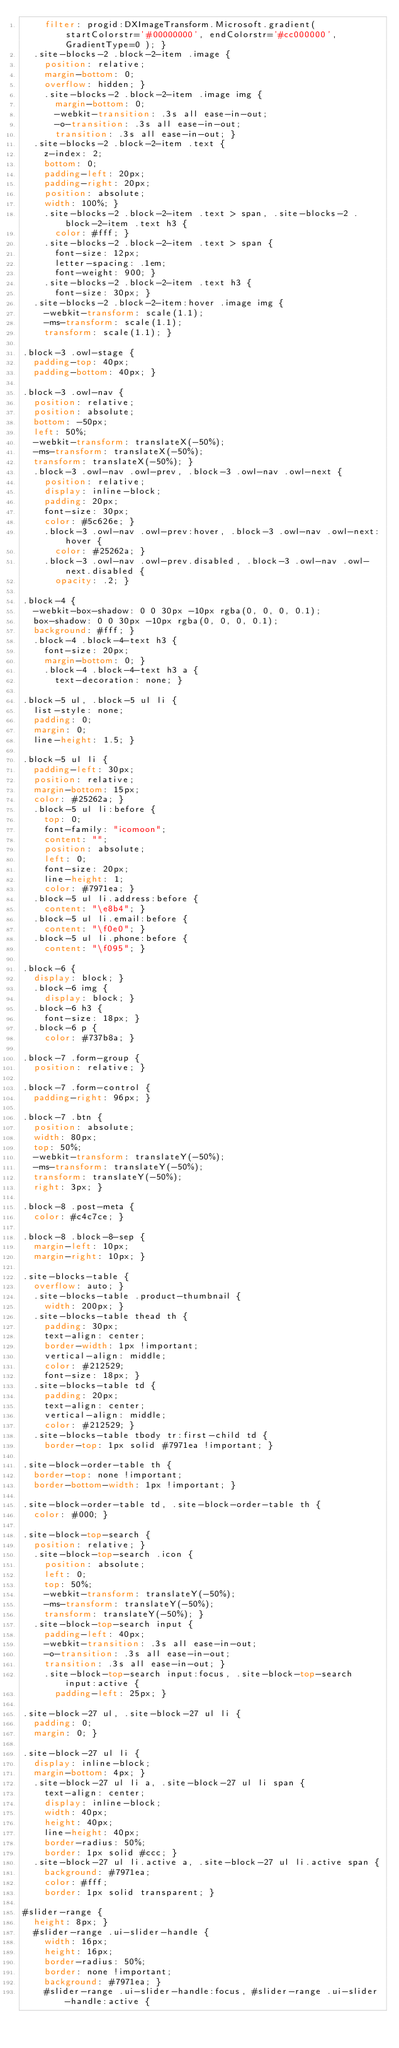Convert code to text. <code><loc_0><loc_0><loc_500><loc_500><_CSS_>    filter: progid:DXImageTransform.Microsoft.gradient( startColorstr='#00000000', endColorstr='#cc000000',GradientType=0 ); }
  .site-blocks-2 .block-2-item .image {
    position: relative;
    margin-bottom: 0;
    overflow: hidden; }
    .site-blocks-2 .block-2-item .image img {
      margin-bottom: 0;
      -webkit-transition: .3s all ease-in-out;
      -o-transition: .3s all ease-in-out;
      transition: .3s all ease-in-out; }
  .site-blocks-2 .block-2-item .text {
    z-index: 2;
    bottom: 0;
    padding-left: 20px;
    padding-right: 20px;
    position: absolute;
    width: 100%; }
    .site-blocks-2 .block-2-item .text > span, .site-blocks-2 .block-2-item .text h3 {
      color: #fff; }
    .site-blocks-2 .block-2-item .text > span {
      font-size: 12px;
      letter-spacing: .1em;
      font-weight: 900; }
    .site-blocks-2 .block-2-item .text h3 {
      font-size: 30px; }
  .site-blocks-2 .block-2-item:hover .image img {
    -webkit-transform: scale(1.1);
    -ms-transform: scale(1.1);
    transform: scale(1.1); }

.block-3 .owl-stage {
  padding-top: 40px;
  padding-bottom: 40px; }

.block-3 .owl-nav {
  position: relative;
  position: absolute;
  bottom: -50px;
  left: 50%;
  -webkit-transform: translateX(-50%);
  -ms-transform: translateX(-50%);
  transform: translateX(-50%); }
  .block-3 .owl-nav .owl-prev, .block-3 .owl-nav .owl-next {
    position: relative;
    display: inline-block;
    padding: 20px;
    font-size: 30px;
    color: #5c626e; }
    .block-3 .owl-nav .owl-prev:hover, .block-3 .owl-nav .owl-next:hover {
      color: #25262a; }
    .block-3 .owl-nav .owl-prev.disabled, .block-3 .owl-nav .owl-next.disabled {
      opacity: .2; }

.block-4 {
  -webkit-box-shadow: 0 0 30px -10px rgba(0, 0, 0, 0.1);
  box-shadow: 0 0 30px -10px rgba(0, 0, 0, 0.1);
  background: #fff; }
  .block-4 .block-4-text h3 {
    font-size: 20px;
    margin-bottom: 0; }
    .block-4 .block-4-text h3 a {
      text-decoration: none; }

.block-5 ul, .block-5 ul li {
  list-style: none;
  padding: 0;
  margin: 0;
  line-height: 1.5; }

.block-5 ul li {
  padding-left: 30px;
  position: relative;
  margin-bottom: 15px;
  color: #25262a; }
  .block-5 ul li:before {
    top: 0;
    font-family: "icomoon";
    content: "";
    position: absolute;
    left: 0;
    font-size: 20px;
    line-height: 1;
    color: #7971ea; }
  .block-5 ul li.address:before {
    content: "\e8b4"; }
  .block-5 ul li.email:before {
    content: "\f0e0"; }
  .block-5 ul li.phone:before {
    content: "\f095"; }

.block-6 {
  display: block; }
  .block-6 img {
    display: block; }
  .block-6 h3 {
    font-size: 18px; }
  .block-6 p {
    color: #737b8a; }

.block-7 .form-group {
  position: relative; }

.block-7 .form-control {
  padding-right: 96px; }

.block-7 .btn {
  position: absolute;
  width: 80px;
  top: 50%;
  -webkit-transform: translateY(-50%);
  -ms-transform: translateY(-50%);
  transform: translateY(-50%);
  right: 3px; }

.block-8 .post-meta {
  color: #c4c7ce; }

.block-8 .block-8-sep {
  margin-left: 10px;
  margin-right: 10px; }

.site-blocks-table {
  overflow: auto; }
  .site-blocks-table .product-thumbnail {
    width: 200px; }
  .site-blocks-table thead th {
    padding: 30px;
    text-align: center;
    border-width: 1px !important;
    vertical-align: middle;
    color: #212529;
    font-size: 18px; }
  .site-blocks-table td {
    padding: 20px;
    text-align: center;
    vertical-align: middle;
    color: #212529; }
  .site-blocks-table tbody tr:first-child td {
    border-top: 1px solid #7971ea !important; }

.site-block-order-table th {
  border-top: none !important;
  border-bottom-width: 1px !important; }

.site-block-order-table td, .site-block-order-table th {
  color: #000; }

.site-block-top-search {
  position: relative; }
  .site-block-top-search .icon {
    position: absolute;
    left: 0;
    top: 50%;
    -webkit-transform: translateY(-50%);
    -ms-transform: translateY(-50%);
    transform: translateY(-50%); }
  .site-block-top-search input {
    padding-left: 40px;
    -webkit-transition: .3s all ease-in-out;
    -o-transition: .3s all ease-in-out;
    transition: .3s all ease-in-out; }
    .site-block-top-search input:focus, .site-block-top-search input:active {
      padding-left: 25px; }

.site-block-27 ul, .site-block-27 ul li {
  padding: 0;
  margin: 0; }

.site-block-27 ul li {
  display: inline-block;
  margin-bottom: 4px; }
  .site-block-27 ul li a, .site-block-27 ul li span {
    text-align: center;
    display: inline-block;
    width: 40px;
    height: 40px;
    line-height: 40px;
    border-radius: 50%;
    border: 1px solid #ccc; }
  .site-block-27 ul li.active a, .site-block-27 ul li.active span {
    background: #7971ea;
    color: #fff;
    border: 1px solid transparent; }

#slider-range {
  height: 8px; }
  #slider-range .ui-slider-handle {
    width: 16px;
    height: 16px;
    border-radius: 50%;
    border: none !important;
    background: #7971ea; }
    #slider-range .ui-slider-handle:focus, #slider-range .ui-slider-handle:active {</code> 